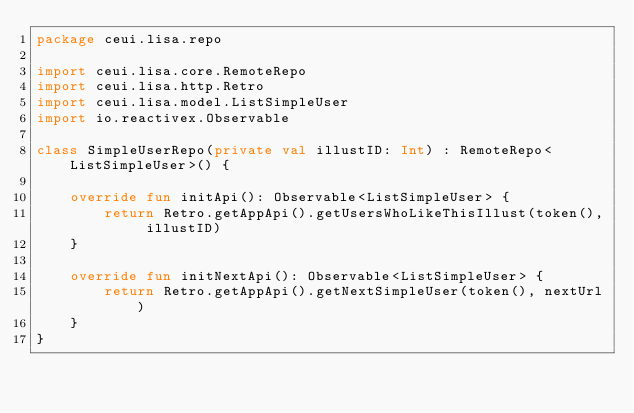<code> <loc_0><loc_0><loc_500><loc_500><_Kotlin_>package ceui.lisa.repo

import ceui.lisa.core.RemoteRepo
import ceui.lisa.http.Retro
import ceui.lisa.model.ListSimpleUser
import io.reactivex.Observable

class SimpleUserRepo(private val illustID: Int) : RemoteRepo<ListSimpleUser>() {

    override fun initApi(): Observable<ListSimpleUser> {
        return Retro.getAppApi().getUsersWhoLikeThisIllust(token(), illustID)
    }

    override fun initNextApi(): Observable<ListSimpleUser> {
        return Retro.getAppApi().getNextSimpleUser(token(), nextUrl)
    }
}
</code> 